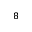<formula> <loc_0><loc_0><loc_500><loc_500>^ { 8 }</formula> 